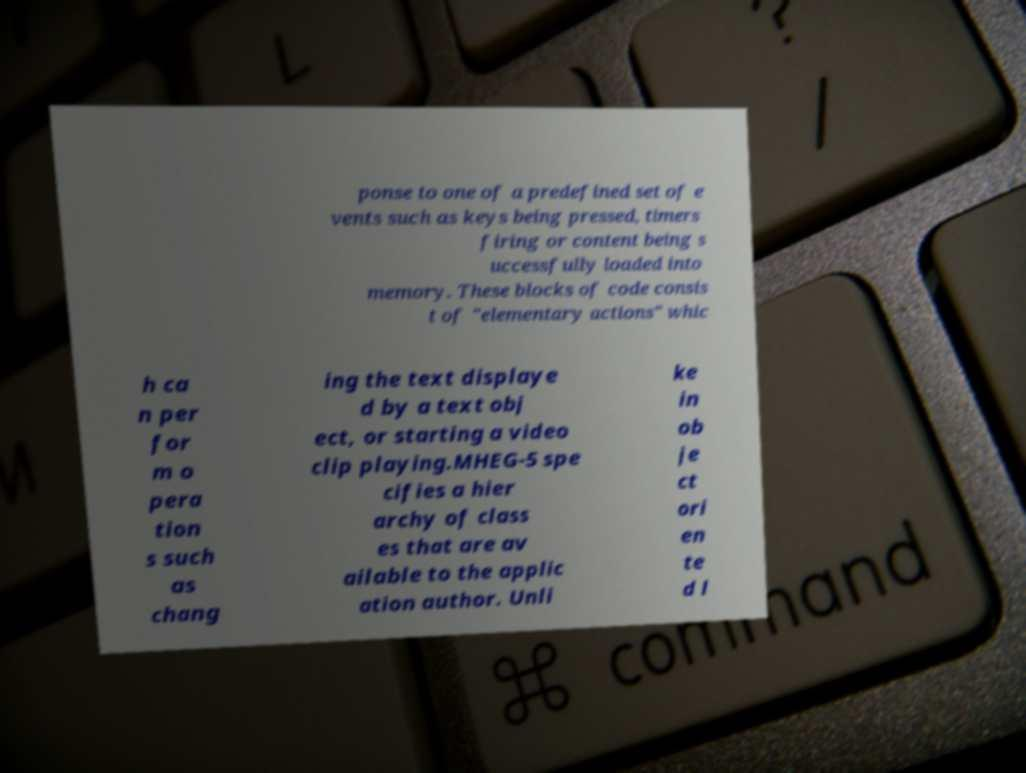I need the written content from this picture converted into text. Can you do that? ponse to one of a predefined set of e vents such as keys being pressed, timers firing or content being s uccessfully loaded into memory. These blocks of code consis t of "elementary actions" whic h ca n per for m o pera tion s such as chang ing the text displaye d by a text obj ect, or starting a video clip playing.MHEG-5 spe cifies a hier archy of class es that are av ailable to the applic ation author. Unli ke in ob je ct ori en te d l 